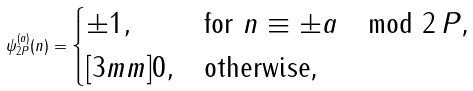<formula> <loc_0><loc_0><loc_500><loc_500>\psi _ { 2 P } ^ { ( a ) } ( n ) = \begin{cases} \pm 1 , & \text {for $n \equiv \pm a \mod 2 \, P$,} \\ [ 3 m m ] 0 , & \text {otherwise,} \end{cases}</formula> 